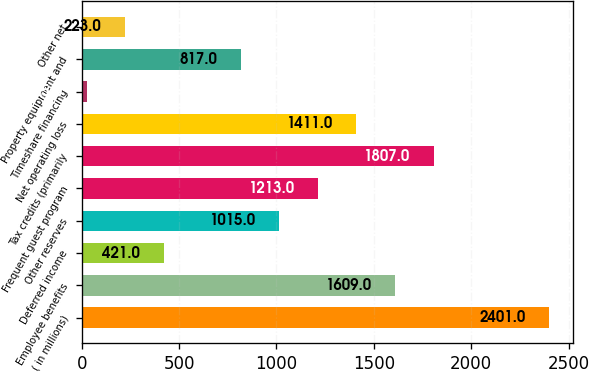Convert chart. <chart><loc_0><loc_0><loc_500><loc_500><bar_chart><fcel>( in millions)<fcel>Employee benefits<fcel>Deferred income<fcel>Other reserves<fcel>Frequent guest program<fcel>Tax credits (primarily<fcel>Net operating loss<fcel>Timeshare financing<fcel>Property equipment and<fcel>Other net<nl><fcel>2401<fcel>1609<fcel>421<fcel>1015<fcel>1213<fcel>1807<fcel>1411<fcel>25<fcel>817<fcel>223<nl></chart> 